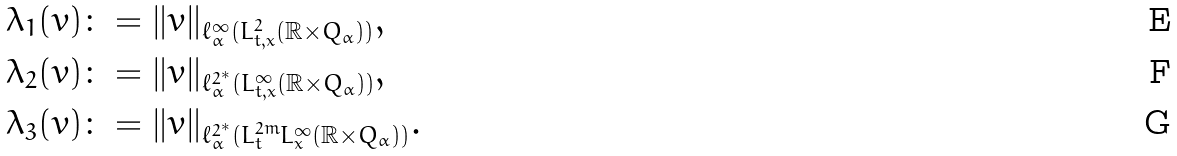Convert formula to latex. <formula><loc_0><loc_0><loc_500><loc_500>& \lambda _ { 1 } ( v ) \colon = \| v \| _ { \ell ^ { \infty } _ { \alpha } ( L ^ { 2 } _ { t , x } ( \mathbb { R } \times Q _ { \alpha } ) ) } , \\ & \lambda _ { 2 } ( v ) \colon = \| v \| _ { \ell ^ { 2 ^ { * } } _ { \alpha } ( L ^ { \infty } _ { t , x } ( \mathbb { R } \times Q _ { \alpha } ) ) } , \\ & \lambda _ { 3 } ( v ) \colon = \| v \| _ { \ell ^ { 2 ^ { * } } _ { \alpha } ( L ^ { 2 m } _ { t } L ^ { \infty } _ { x } ( \mathbb { R } \times Q _ { \alpha } ) ) } .</formula> 